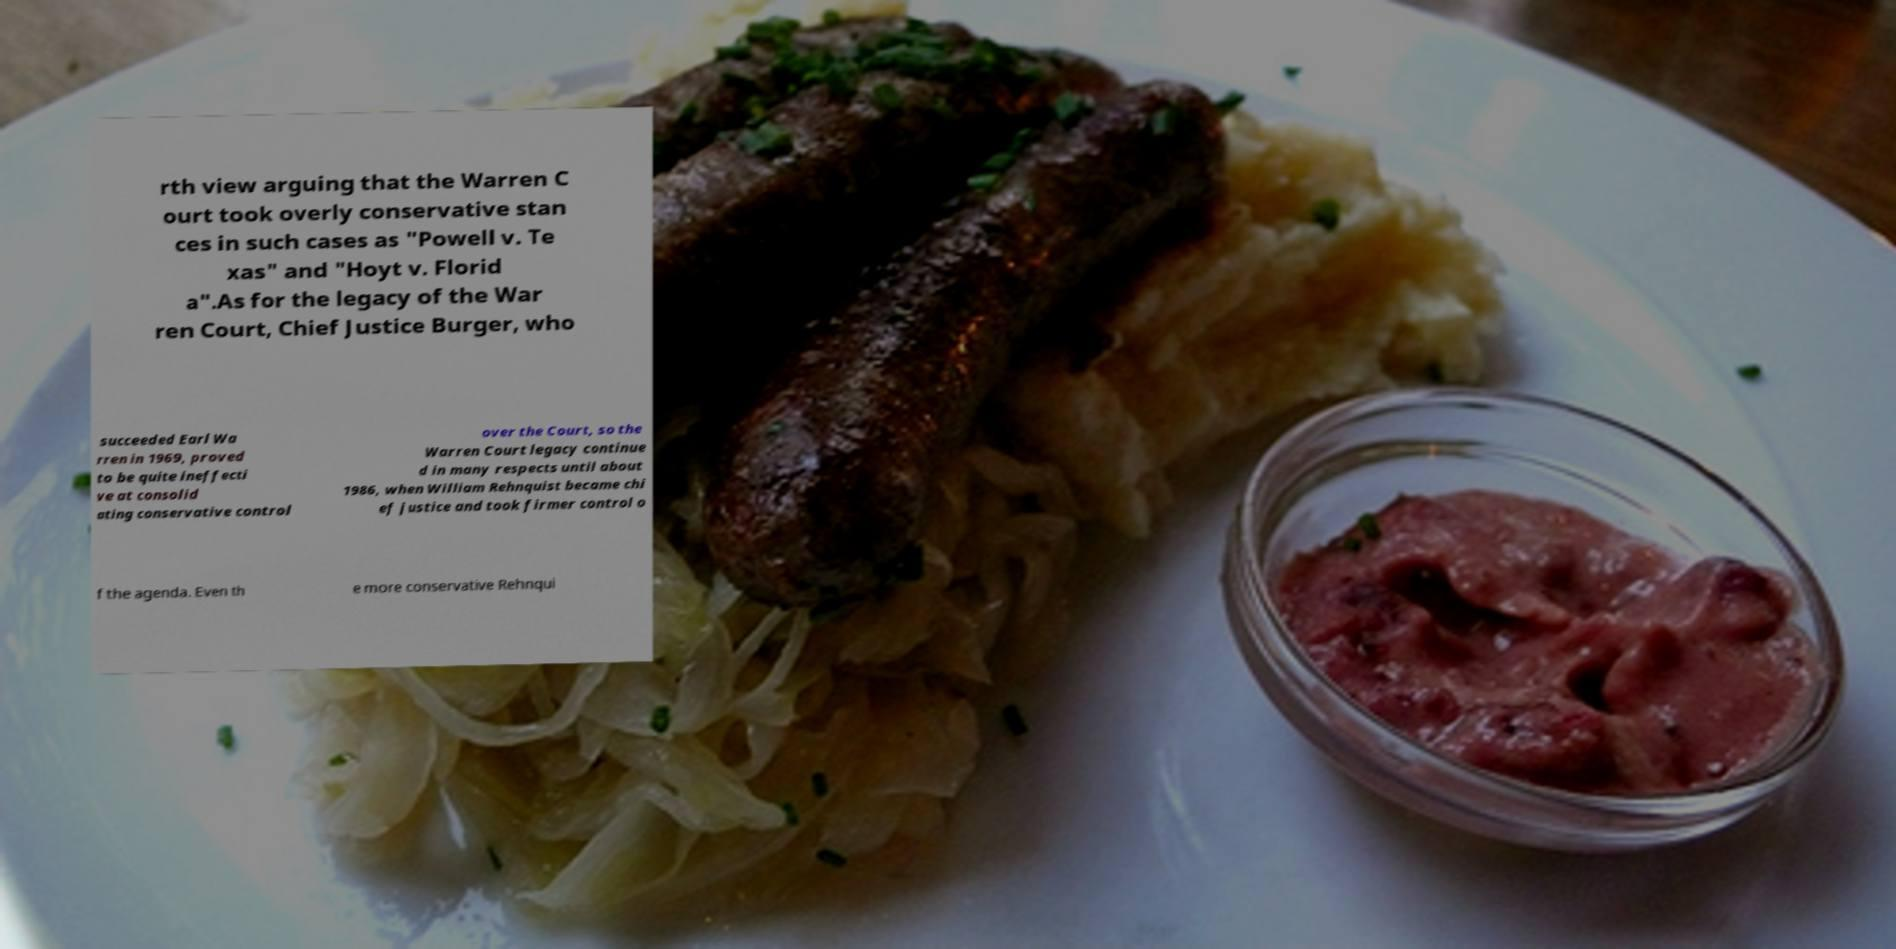Please identify and transcribe the text found in this image. rth view arguing that the Warren C ourt took overly conservative stan ces in such cases as "Powell v. Te xas" and "Hoyt v. Florid a".As for the legacy of the War ren Court, Chief Justice Burger, who succeeded Earl Wa rren in 1969, proved to be quite ineffecti ve at consolid ating conservative control over the Court, so the Warren Court legacy continue d in many respects until about 1986, when William Rehnquist became chi ef justice and took firmer control o f the agenda. Even th e more conservative Rehnqui 